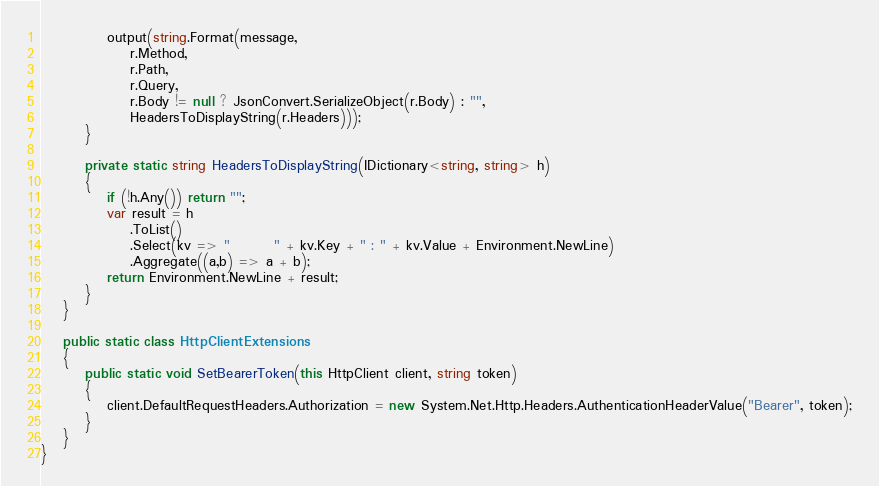Convert code to text. <code><loc_0><loc_0><loc_500><loc_500><_C#_>            output(string.Format(message, 
                r.Method, 
                r.Path, 
                r.Query, 
                r.Body != null ? JsonConvert.SerializeObject(r.Body) : "", 
                HeadersToDisplayString(r.Headers)));
        }

        private static string HeadersToDisplayString(IDictionary<string, string> h)
        {
            if (!h.Any()) return "";
            var result = h
                .ToList()
                .Select(kv => "        " + kv.Key + " : " + kv.Value + Environment.NewLine)
                .Aggregate((a,b) => a + b);
            return Environment.NewLine + result;
        }
    }
    
    public static class HttpClientExtensions
    {
        public static void SetBearerToken(this HttpClient client, string token)
        {
            client.DefaultRequestHeaders.Authorization = new System.Net.Http.Headers.AuthenticationHeaderValue("Bearer", token);
        }
    }
}</code> 